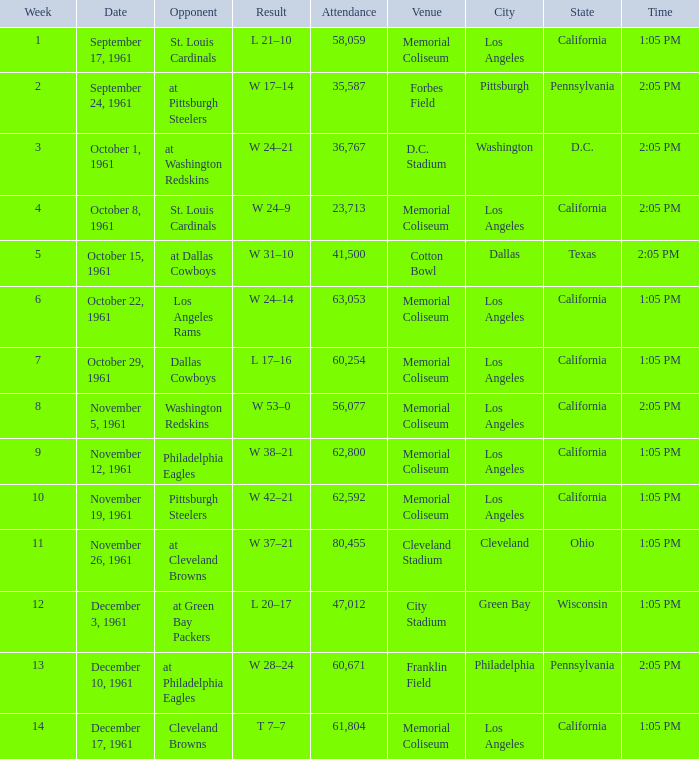Which Week has an Opponent of washington redskins, and an Attendance larger than 56,077? 0.0. 